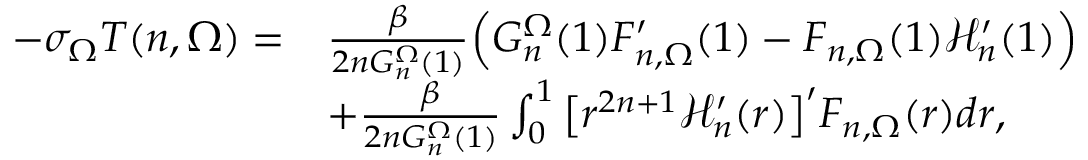Convert formula to latex. <formula><loc_0><loc_0><loc_500><loc_500>\begin{array} { r l } { - \sigma _ { \Omega } T ( n , \Omega ) = } & { \frac { \beta } { 2 n G _ { n } ^ { \Omega } ( 1 ) } \left ( G _ { n } ^ { \Omega } ( 1 ) F _ { n , \Omega } ^ { \prime } ( 1 ) - F _ { n , \Omega } ( 1 ) \mathcal { H } _ { n } ^ { \prime } ( 1 ) \right ) } \\ & { + \frac { \beta } { 2 n G _ { n } ^ { \Omega } ( 1 ) } \int _ { 0 } ^ { 1 } \left [ r ^ { 2 n + 1 } \mathcal { H } _ { n } ^ { \prime } ( r ) \right ] ^ { \prime } F _ { n , \Omega } ( r ) d r , } \end{array}</formula> 